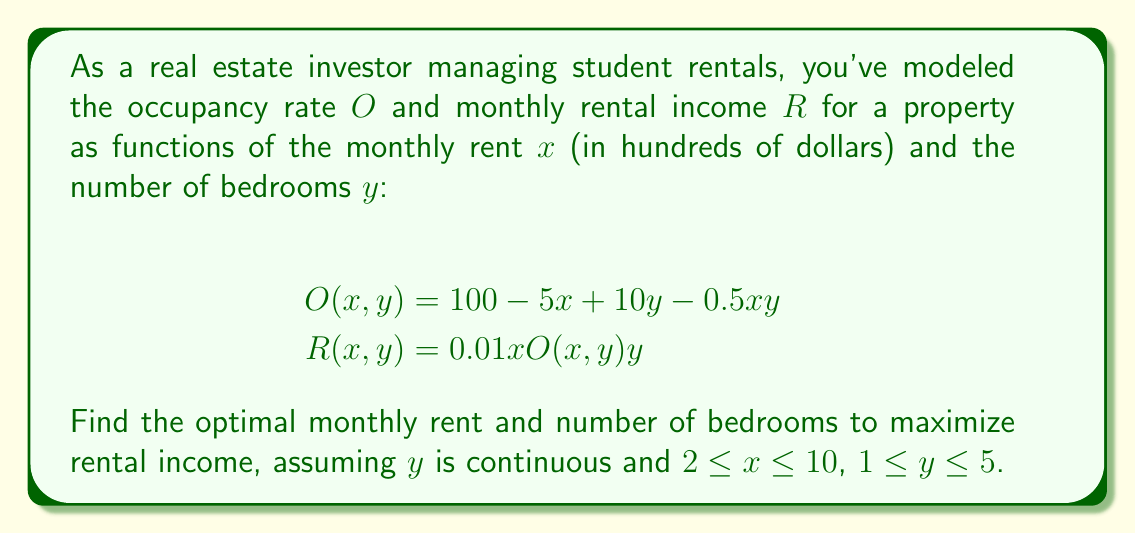Teach me how to tackle this problem. To maximize rental income, we need to find the critical points of $R(x,y)$ within the given constraints.

Step 1: Calculate partial derivatives
$$\frac{\partial R}{\partial x} = 0.01O(x,y)y + 0.01xy\frac{\partial O}{\partial x}$$
$$\frac{\partial R}{\partial y} = 0.01xO(x,y) + 0.01xy\frac{\partial O}{\partial y}$$

Step 2: Substitute $O(x,y)$ and its partial derivatives
$$\frac{\partial O}{\partial x} = -5 - 0.5y$$
$$\frac{\partial O}{\partial y} = 10 - 0.5x$$

$$\frac{\partial R}{\partial x} = 0.01(100 - 5x + 10y - 0.5xy)y + 0.01xy(-5 - 0.5y)$$
$$\frac{\partial R}{\partial y} = 0.01x(100 - 5x + 10y - 0.5xy) + 0.01xy(10 - 0.5x)$$

Step 3: Set partial derivatives to zero and solve
$$\frac{\partial R}{\partial x} = y - 0.5xy - 0.05x^2y = 0$$
$$\frac{\partial R}{\partial y} = x - 0.05x^2 + 0.1xy - 0.005x^2y = 0$$

Step 4: Simplify equations
$$2 - x - 0.1x^2 = 0$$
$$20 - x + 2y - 0.1xy = 0$$

Step 5: Solve for x in the first equation
$$x^2 + 10x - 20 = 0$$
$$x = 5(\sqrt{5} - 1) \approx 6.18$$

Step 6: Substitute x into the second equation and solve for y
$$y = \frac{x - 20}{2 - 0.1x} \approx 3.82$$

Step 7: Check constraints
$x \approx 6.18$ is within $[2, 10]$
$y \approx 3.82$ is within $[1, 5]$

Step 8: Verify second partial derivatives for maximum
$$\frac{\partial^2 R}{\partial x^2} < 0, \frac{\partial^2 R}{\partial y^2} < 0, \text{ and } \frac{\partial^2 R}{\partial x^2}\frac{\partial^2 R}{\partial y^2} - \left(\frac{\partial^2 R}{\partial x\partial y}\right)^2 > 0$$

These conditions are satisfied at the critical point, confirming a local maximum.
Answer: $x \approx 6.18, y \approx 3.82$ 